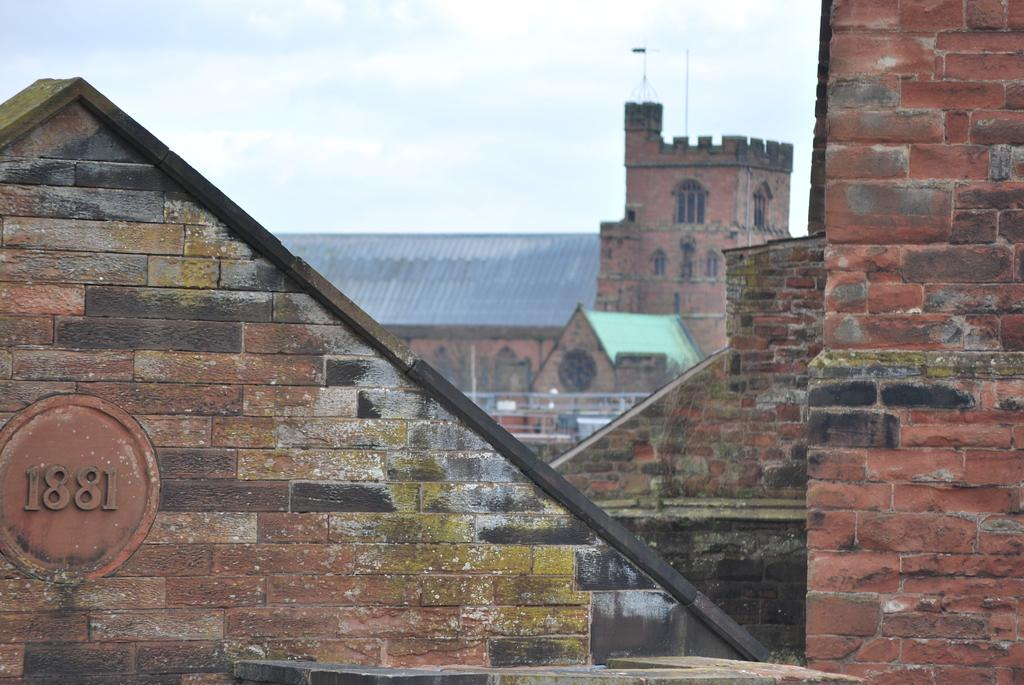What type of structures are present in the image? There are buildings in the image. What colors are the buildings? The buildings are in brown and gray colors. What else can be seen in the image besides the buildings? There are poles in the image. What is visible in the background of the image? The sky is visible in the background of the image. What color is the sky in the image? The sky is white in color. What is the level of interest in the picture? The level of interest in the picture cannot be determined from the image itself, as it is subjective and depends on the viewer's preferences. 